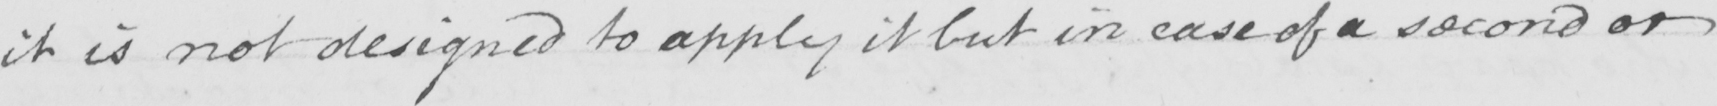Transcribe the text shown in this historical manuscript line. it is not designed to apply it but in case of a second or 